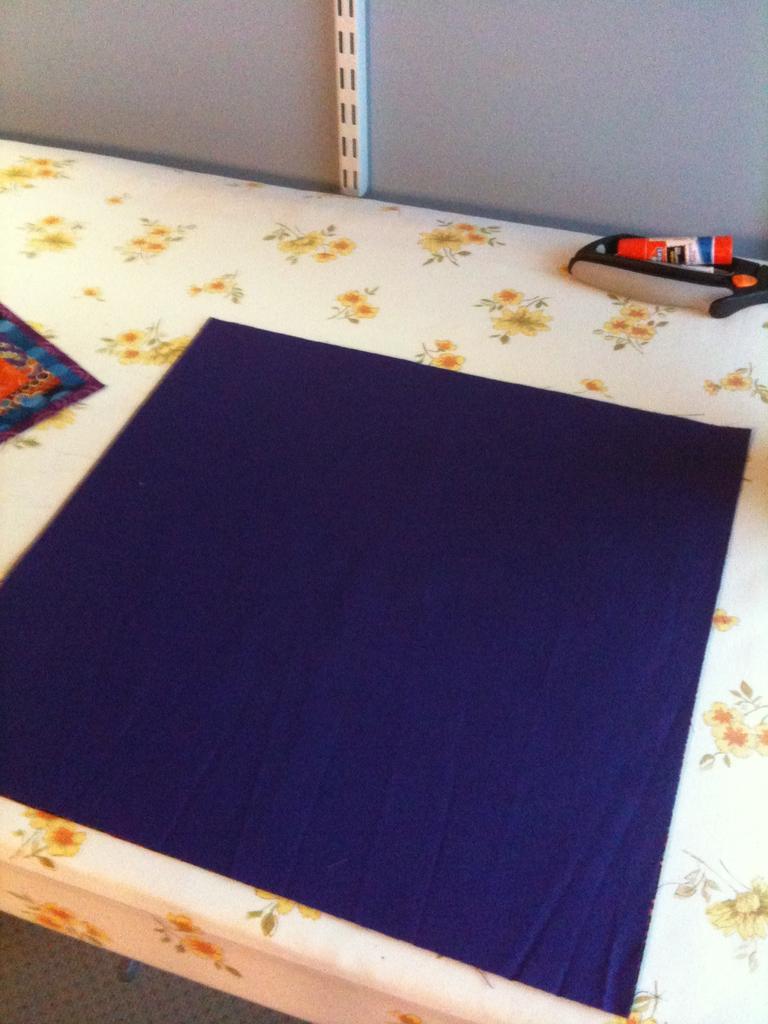Please provide a concise description of this image. In the image there is a table with floral cloth. On the table there is a blue cloth. And also there are few items on the table. Behind the table there is a wall with an object. 